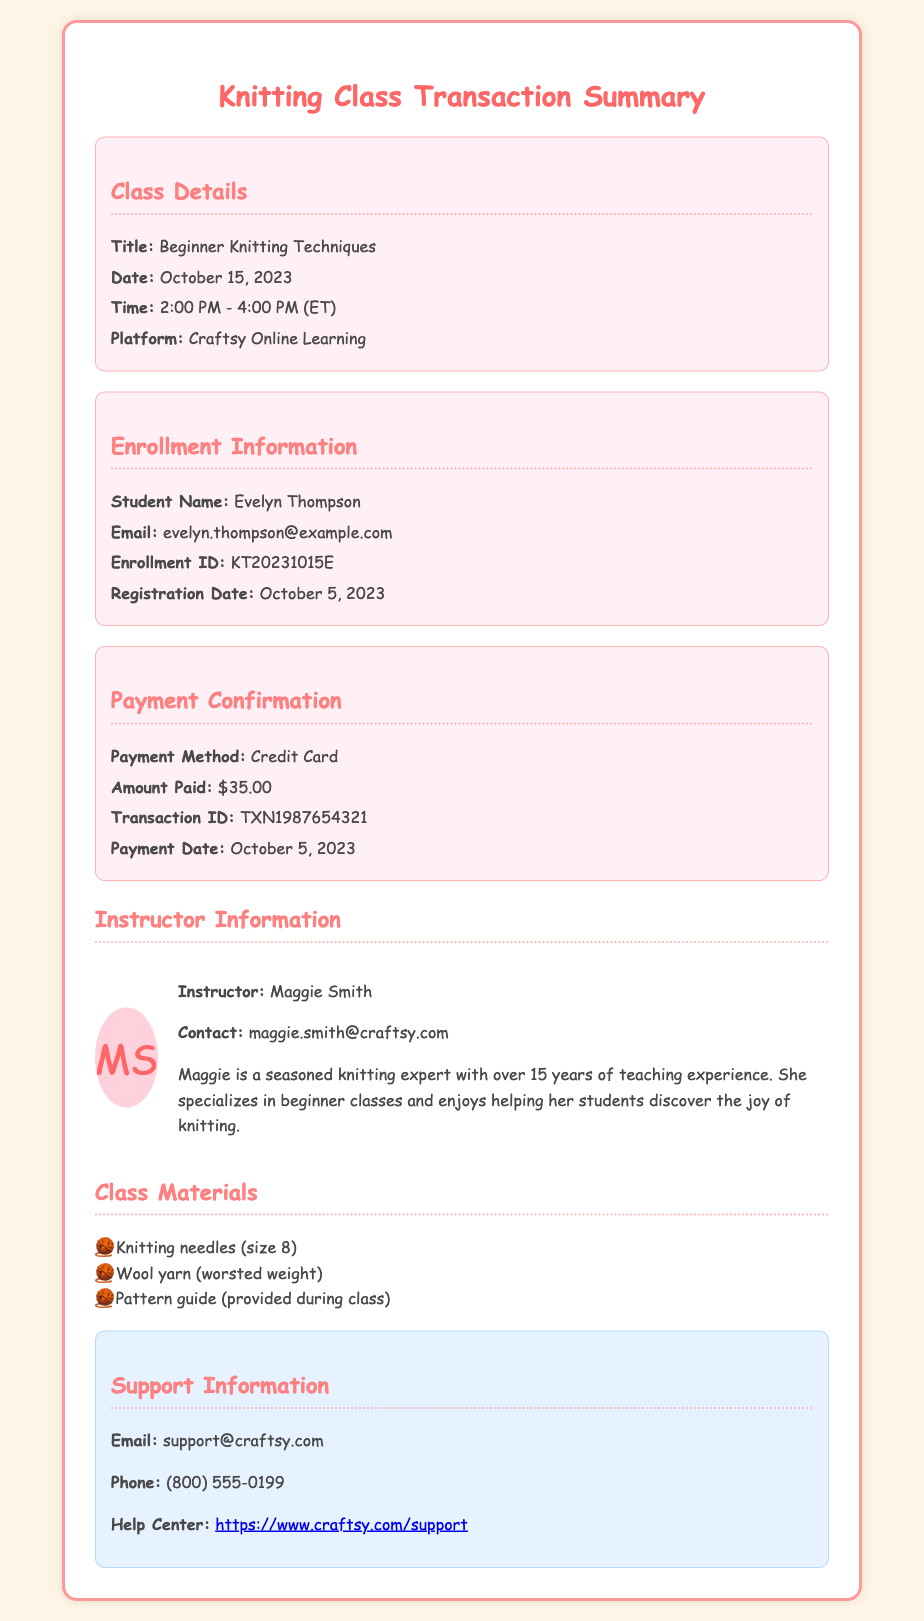What is the title of the class? The title of the class is mentioned under Class Details.
Answer: Beginner Knitting Techniques Who is the instructor? The instructor's name is provided in the Instructor Information section.
Answer: Maggie Smith What is the payment amount? The amount paid is stated in the Payment Confirmation section.
Answer: $35.00 What is the date of the class? The date of the class is listed in the Class Details section.
Answer: October 15, 2023 What is Evelyn Thompson's enrollment ID? The enrollment ID can be found in the Enrollment Information section.
Answer: KT20231015E How many years of teaching experience does the instructor have? The instructor's experience is mentioned in the Instructor Information.
Answer: 15 years What is the registration date? The registration date is given in the Enrollment Information section.
Answer: October 5, 2023 What platform will the class be held on? The platform for the class is specified in the Class Details section.
Answer: Craftsy Online Learning Which knitting needles are needed for the class? The list of required materials includes knitting needles under Class Materials.
Answer: size 8 